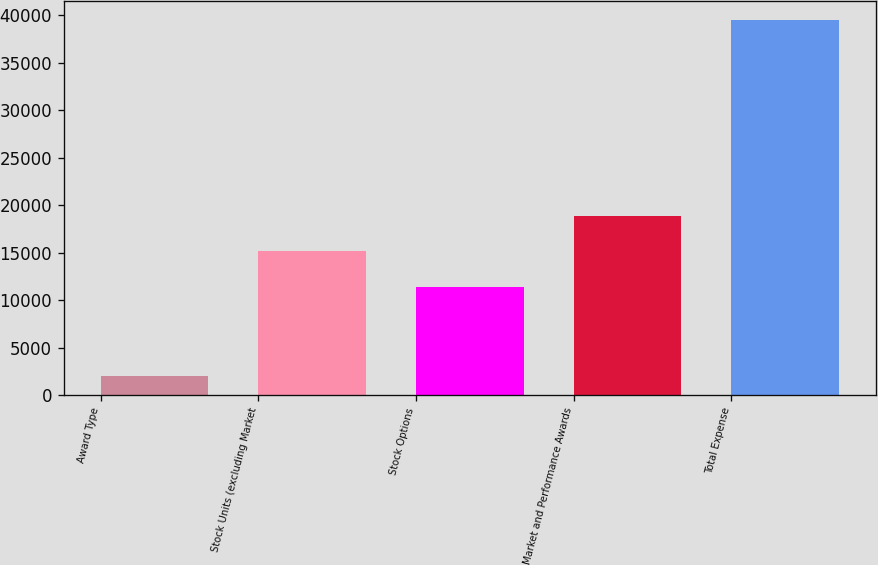Convert chart. <chart><loc_0><loc_0><loc_500><loc_500><bar_chart><fcel>Award Type<fcel>Stock Units (excluding Market<fcel>Stock Options<fcel>Market and Performance Awards<fcel>Total Expense<nl><fcel>2013<fcel>15135.5<fcel>11385<fcel>18886<fcel>39518<nl></chart> 